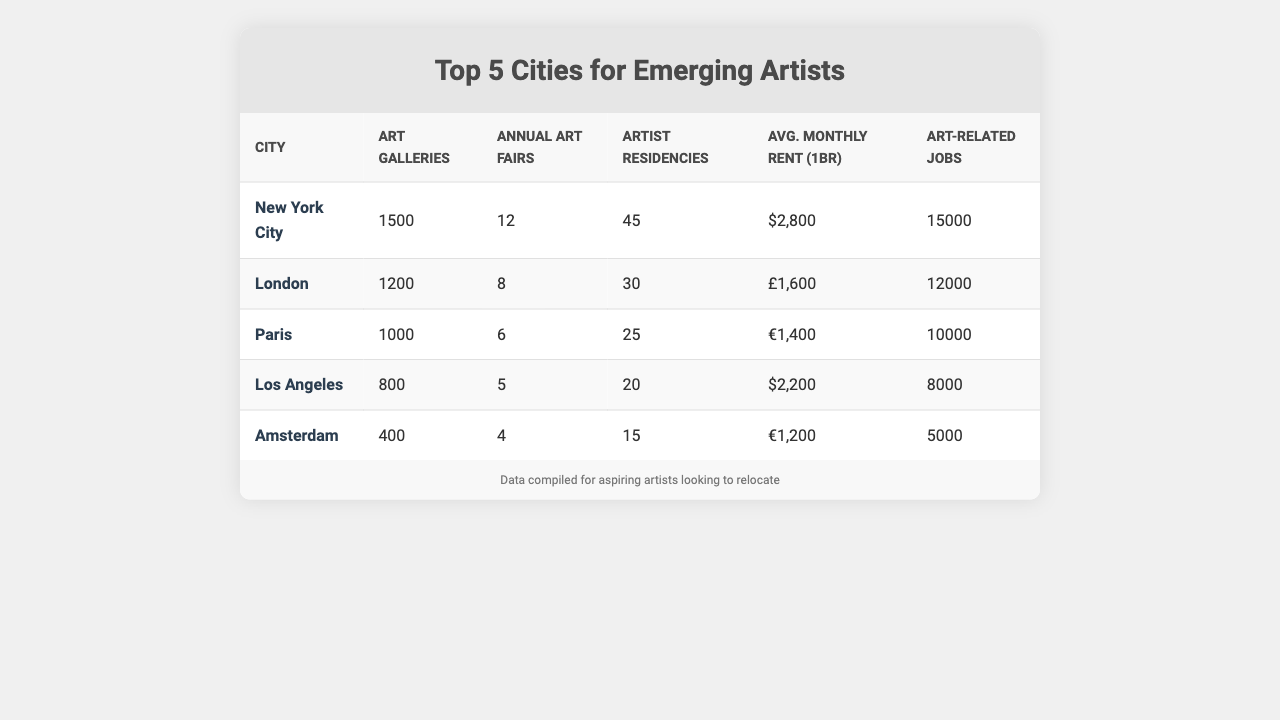What city has the highest number of art galleries? By looking at the table, New York City has 1500 art galleries, which is the highest figure compared to other cities listed.
Answer: New York City How many artist residencies does Paris have? The table shows that Paris has 25 artist residencies, which can be seen in the corresponding row for Paris.
Answer: 25 Which city has the lowest average monthly rent for a 1-bedroom apartment? Amsterdam has the lowest average monthly rent listed at €1,200, making it the most affordable city for rent in the table.
Answer: €1,200 What is the total number of art-related jobs across all five cities? To find the total, add the number of art-related jobs: 15000 + 12000 + 10000 + 8000 + 5000 = 60000. Thus, the total number of art-related jobs is 60000.
Answer: 60000 How many more annual art fairs does New York City have compared to Amsterdam? New York City has 12 annual art fairs, while Amsterdam has 4. The difference is 12 - 4 = 8, indicating that New York City has 8 more annual art fairs than Amsterdam.
Answer: 8 Is it true that Los Angeles has more artist residencies than Amsterdam? By comparing the numbers from the table, Los Angeles has 20 artist residencies while Amsterdam has 15. Since 20 is greater than 15, the statement is true.
Answer: True Which city has the highest average monthly rent? From the data, New York City has the highest average rent at $2,800, which is higher than all the other cities posted in the table.
Answer: $2,800 What is the average number of art galleries in the top 5 cities? To find the average, sum the number of art galleries (1500 + 1200 + 1000 + 800 + 400) = 3900, and then divide by 5: 3900 / 5 = 780. Therefore, the average number of art galleries is 780.
Answer: 780 Considering job opportunities and rent, which city offers the most jobs per dollar spent on rent (use New York City and Amsterdam for the comparison)? For New York City, the rent is $2800 and jobs are 15000: 15000 / 2800 = 5.36. For Amsterdam, the rent is $1200 and jobs are 5000: 5000 / 1200 = 4.17. Thus, New York City has a higher ratio of jobs per dollar spent on rent.
Answer: New York City How many total art fairs does London and Paris have together? Add the total number of art fairs from London and Paris: 8 (London) + 6 (Paris) = 14. Thus, together, they have 14 art fairs.
Answer: 14 